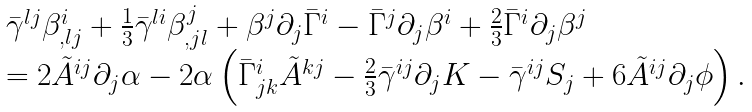Convert formula to latex. <formula><loc_0><loc_0><loc_500><loc_500>\begin{array} { r c l } & & \bar { \gamma } ^ { l j } \beta ^ { i } _ { , l j } + \frac { 1 } { 3 } \bar { \gamma } ^ { l i } \beta ^ { j } _ { , j l } + \beta ^ { j } \partial _ { j } \bar { \Gamma } ^ { i } - \bar { \Gamma } ^ { j } \partial _ { j } \beta ^ { i } + \frac { 2 } { 3 } \bar { \Gamma } ^ { i } \partial _ { j } \beta ^ { j } \\ & & = 2 \tilde { A } ^ { i j } \partial _ { j } \alpha - 2 \alpha \left ( \bar { \Gamma } ^ { i } _ { j k } \tilde { A } ^ { k j } - \frac { 2 } { 3 } \bar { \gamma } ^ { i j } \partial _ { j } K - \bar { \gamma } ^ { i j } S _ { j } + 6 \tilde { A } ^ { i j } \partial _ { j } \phi \right ) . \end{array}</formula> 